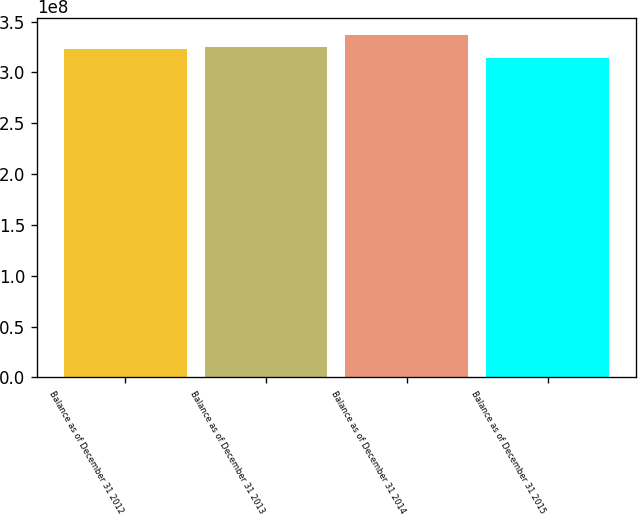Convert chart to OTSL. <chart><loc_0><loc_0><loc_500><loc_500><bar_chart><fcel>Balance as of December 31 2012<fcel>Balance as of December 31 2013<fcel>Balance as of December 31 2014<fcel>Balance as of December 31 2015<nl><fcel>3.22607e+08<fcel>3.24854e+08<fcel>3.36663e+08<fcel>3.1419e+08<nl></chart> 